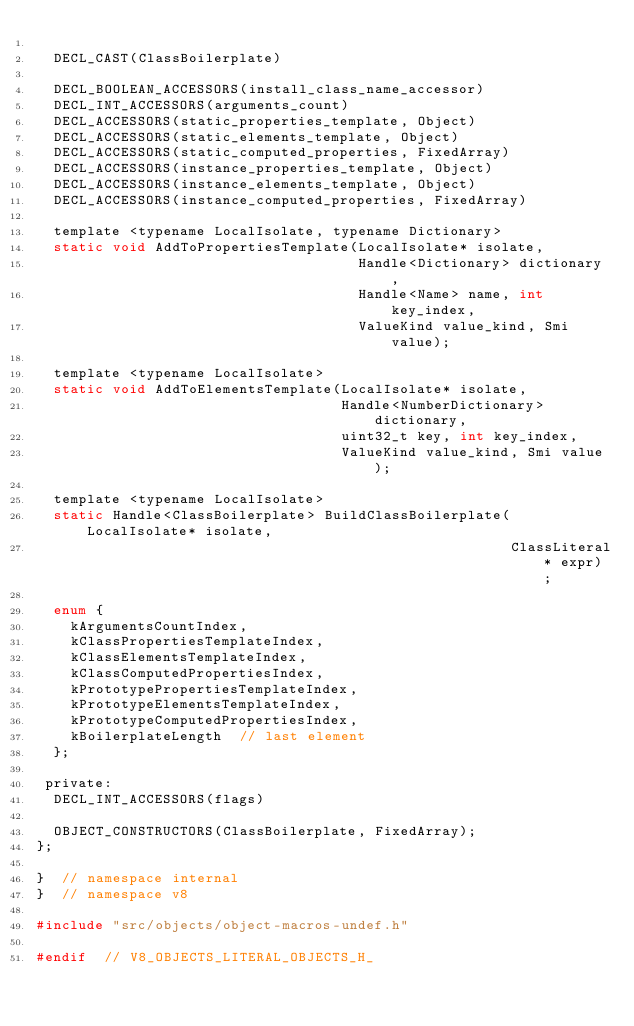Convert code to text. <code><loc_0><loc_0><loc_500><loc_500><_C_>
  DECL_CAST(ClassBoilerplate)

  DECL_BOOLEAN_ACCESSORS(install_class_name_accessor)
  DECL_INT_ACCESSORS(arguments_count)
  DECL_ACCESSORS(static_properties_template, Object)
  DECL_ACCESSORS(static_elements_template, Object)
  DECL_ACCESSORS(static_computed_properties, FixedArray)
  DECL_ACCESSORS(instance_properties_template, Object)
  DECL_ACCESSORS(instance_elements_template, Object)
  DECL_ACCESSORS(instance_computed_properties, FixedArray)

  template <typename LocalIsolate, typename Dictionary>
  static void AddToPropertiesTemplate(LocalIsolate* isolate,
                                      Handle<Dictionary> dictionary,
                                      Handle<Name> name, int key_index,
                                      ValueKind value_kind, Smi value);

  template <typename LocalIsolate>
  static void AddToElementsTemplate(LocalIsolate* isolate,
                                    Handle<NumberDictionary> dictionary,
                                    uint32_t key, int key_index,
                                    ValueKind value_kind, Smi value);

  template <typename LocalIsolate>
  static Handle<ClassBoilerplate> BuildClassBoilerplate(LocalIsolate* isolate,
                                                        ClassLiteral* expr);

  enum {
    kArgumentsCountIndex,
    kClassPropertiesTemplateIndex,
    kClassElementsTemplateIndex,
    kClassComputedPropertiesIndex,
    kPrototypePropertiesTemplateIndex,
    kPrototypeElementsTemplateIndex,
    kPrototypeComputedPropertiesIndex,
    kBoilerplateLength  // last element
  };

 private:
  DECL_INT_ACCESSORS(flags)

  OBJECT_CONSTRUCTORS(ClassBoilerplate, FixedArray);
};

}  // namespace internal
}  // namespace v8

#include "src/objects/object-macros-undef.h"

#endif  // V8_OBJECTS_LITERAL_OBJECTS_H_
</code> 